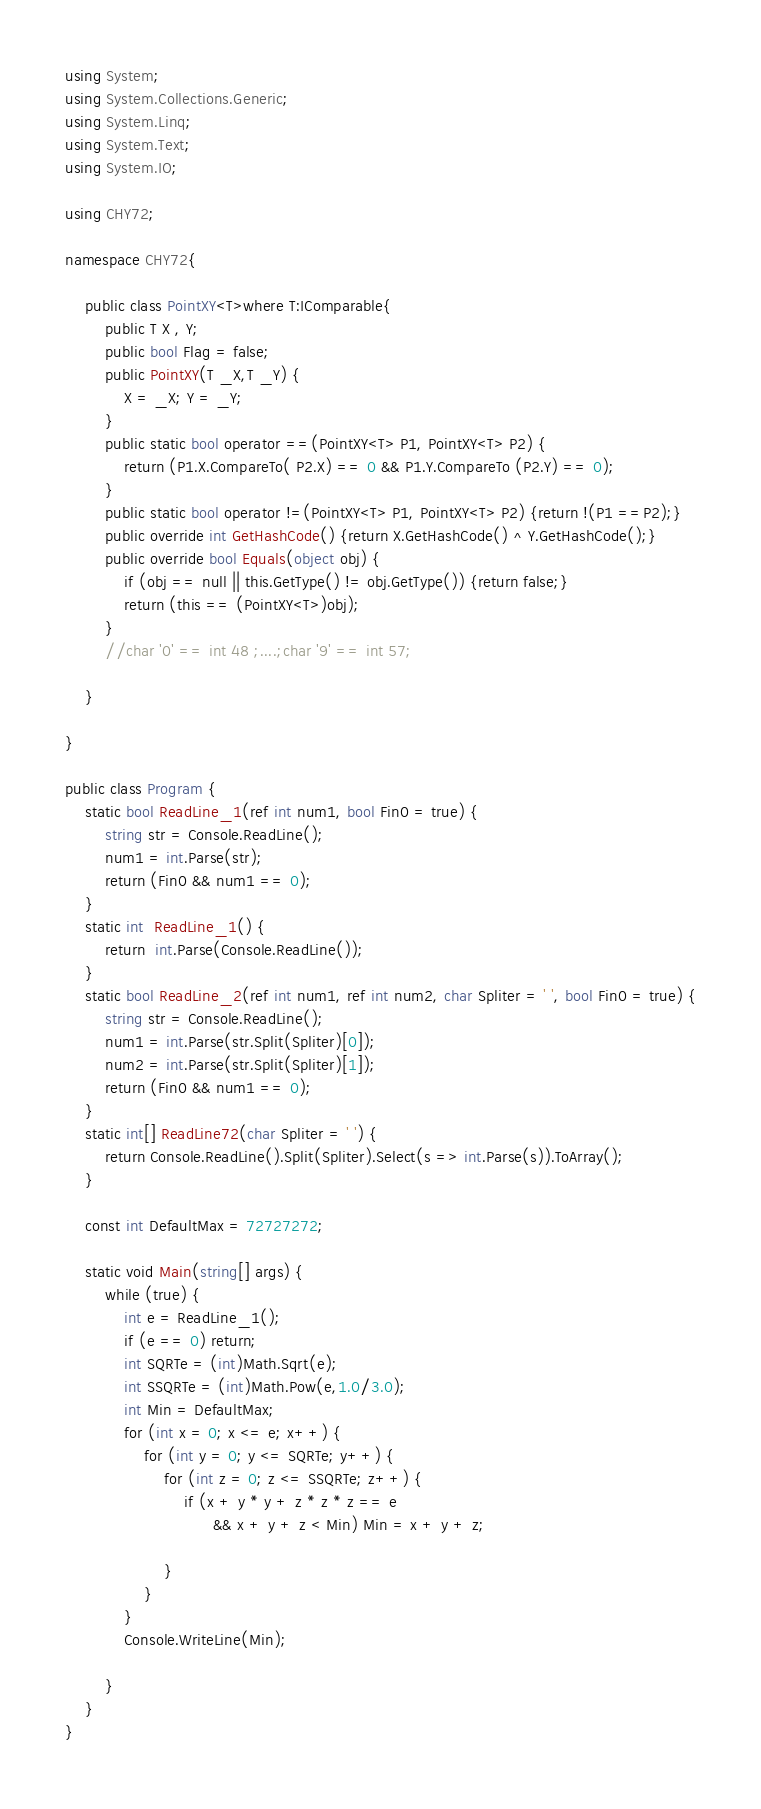<code> <loc_0><loc_0><loc_500><loc_500><_C#_>using System;
using System.Collections.Generic;
using System.Linq;
using System.Text;
using System.IO;

using CHY72;

namespace CHY72{
    
    public class PointXY<T>where T:IComparable{
        public T X , Y;
        public bool Flag = false;
        public PointXY(T _X,T _Y) {
            X = _X; Y = _Y;
        }
        public static bool operator ==(PointXY<T> P1, PointXY<T> P2) {
            return (P1.X.CompareTo( P2.X) == 0 && P1.Y.CompareTo (P2.Y) == 0);
        }
        public static bool operator !=(PointXY<T> P1, PointXY<T> P2) {return !(P1 ==P2);}
        public override int GetHashCode() {return X.GetHashCode() ^ Y.GetHashCode();}
        public override bool Equals(object obj) {
            if (obj == null || this.GetType() != obj.GetType()) {return false;}
            return (this == (PointXY<T>)obj);
        }
        //char '0' == int 48 ;....;char '9' == int 57;

    }
    
}    

public class Program {
    static bool ReadLine_1(ref int num1, bool Fin0 = true) {
        string str = Console.ReadLine();
        num1 = int.Parse(str);
        return (Fin0 && num1 == 0);
    }
    static int  ReadLine_1() {
        return  int.Parse(Console.ReadLine());
    }
    static bool ReadLine_2(ref int num1, ref int num2, char Spliter = ' ', bool Fin0 = true) {
        string str = Console.ReadLine();
        num1 = int.Parse(str.Split(Spliter)[0]);
        num2 = int.Parse(str.Split(Spliter)[1]);
        return (Fin0 && num1 == 0);
    }
    static int[] ReadLine72(char Spliter = ' ') {
        return Console.ReadLine().Split(Spliter).Select(s => int.Parse(s)).ToArray();
    }

    const int DefaultMax = 72727272;

    static void Main(string[] args) {
        while (true) {
            int e = ReadLine_1();
            if (e == 0) return;
            int SQRTe = (int)Math.Sqrt(e);
            int SSQRTe = (int)Math.Pow(e,1.0/3.0);
            int Min = DefaultMax;
            for (int x = 0; x <= e; x++) {
                for (int y = 0; y <= SQRTe; y++) {
                    for (int z = 0; z <= SSQRTe; z++) {
                        if (x + y * y + z * z * z == e
                              && x + y + z < Min) Min = x + y + z; 
                        
                    }                
                }
            }
            Console.WriteLine(Min);

        }
    }
}</code> 